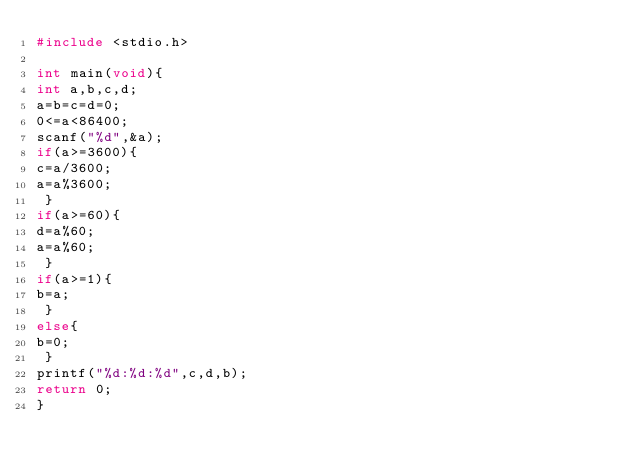<code> <loc_0><loc_0><loc_500><loc_500><_C_>#include <stdio.h>
   
int main(void){
int a,b,c,d;
a=b=c=d=0;
0<=a<86400;
scanf("%d",&a);
if(a>=3600){
c=a/3600;
a=a%3600;
 }
if(a>=60){
d=a%60;
a=a%60;
 }
if(a>=1){
b=a;
 }
else{
b=0;
 }
printf("%d:%d:%d",c,d,b);
return 0;
}</code> 